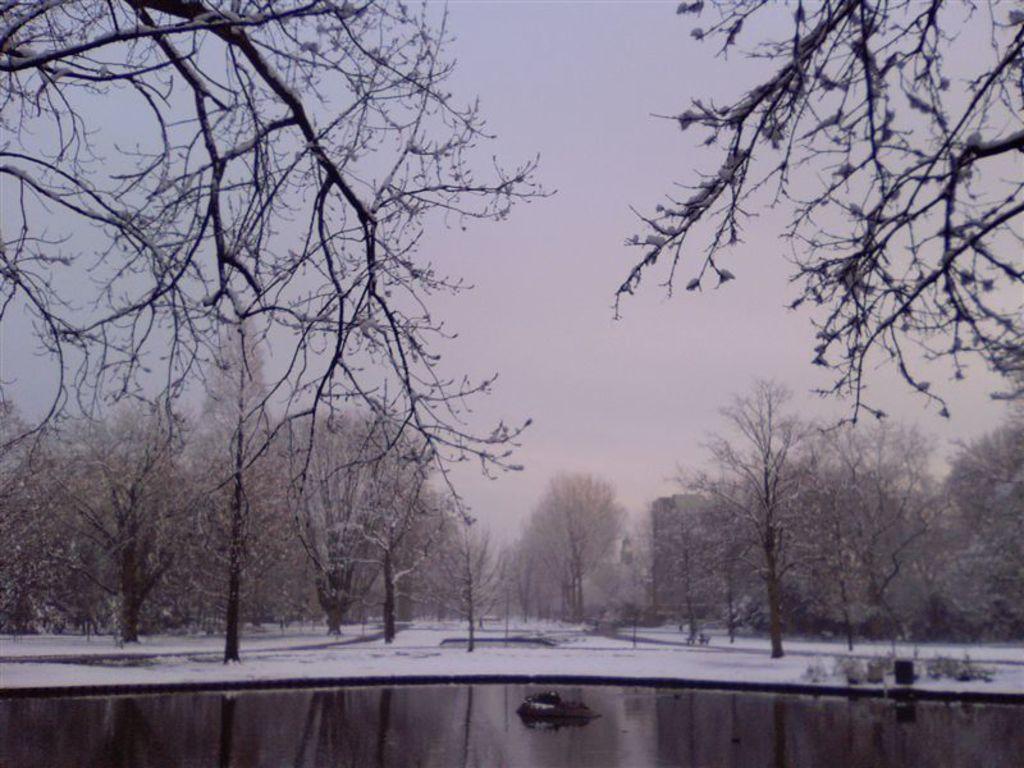Please provide a concise description of this image. In the center of the image we can see the sky, trees, snow, water and a few other objects. At the top of the image, we can see branches. 